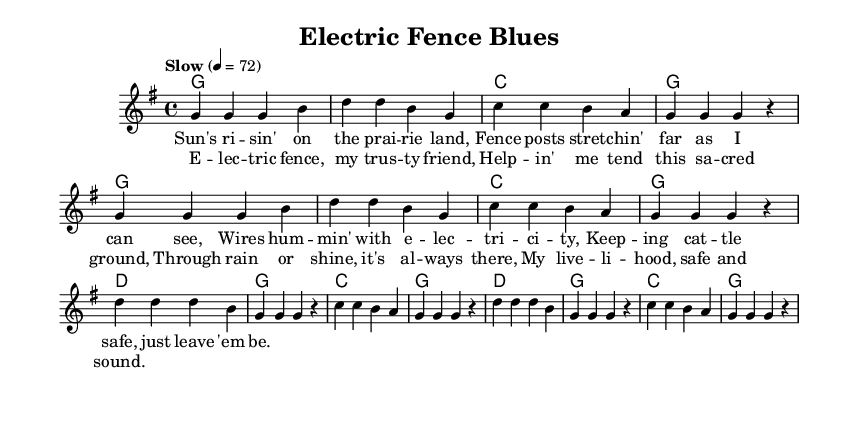What is the key signature of this music? The key signature is G major, which has one sharp (F#). It is indicated at the beginning of the staff.
Answer: G major What is the time signature of this piece? The time signature is 4/4, which means there are four beats in each measure, and the quarter note gets one beat. This is displayed at the beginning of the music.
Answer: 4/4 What is the tempo marking for this song? The tempo marking is "Slow" with a metronome marking of 72 beats per minute, which indicates the speed at which the piece should be played.
Answer: Slow, 72 How many measures are in the verse section? The verse section consists of 8 measures, as indicated by the number of distinct groups of notes divided by vertical bar lines.
Answer: 8 What is the main theme of the lyrics? The main theme of the lyrics focuses on the relationship between a farmer and electric fencing, emphasizing safety and reliability in farming life. This is evident from the line referencing the fence's role in keeping cattle safe.
Answer: Farming safety What chords are used in the chorus? The chords in the chorus are D major, G major, and C major. Observing the chord changes written above the melody supports this.
Answer: D, G, C What role does the electric fence play in the lyrics? The electric fence is described as a trusted companion that supports the farmer in protecting their livelihood, highlighting its significance in their daily work. This is explained in the chorus lines.
Answer: Trusted companion 